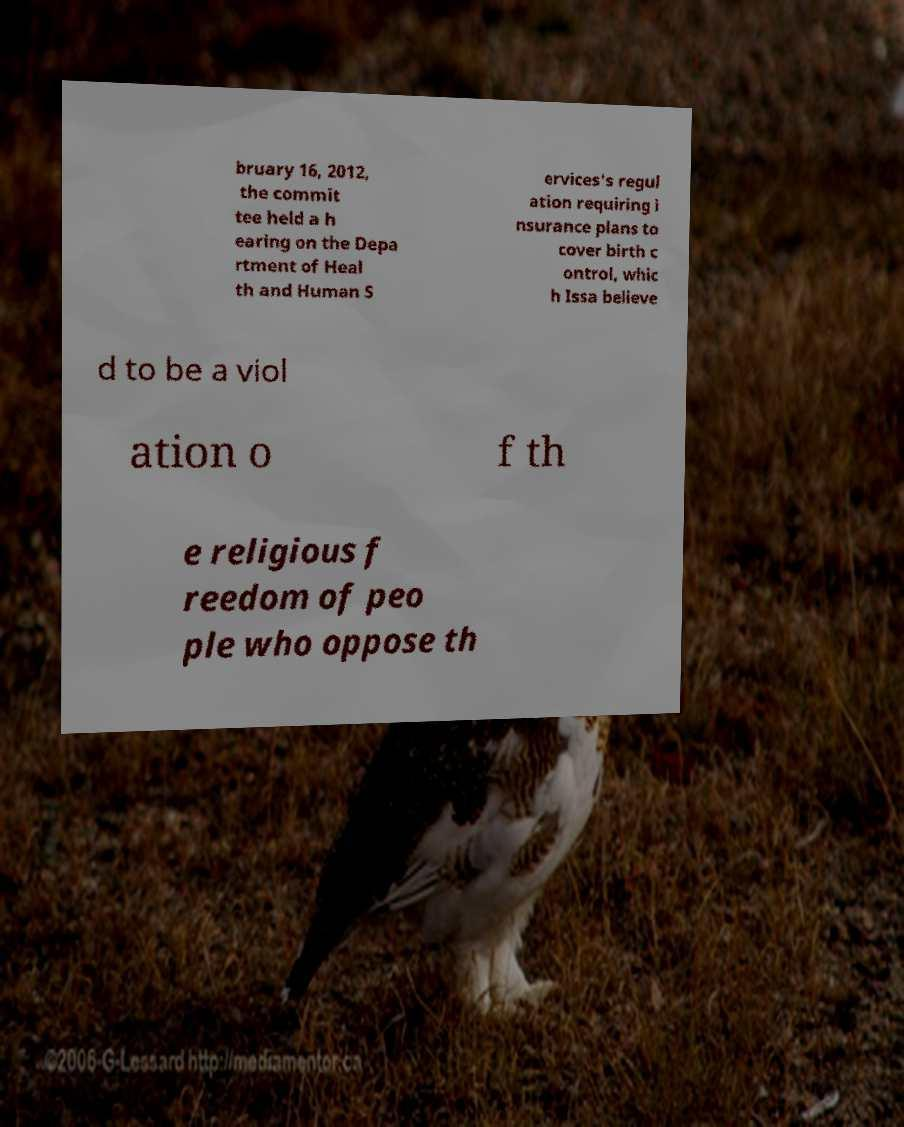Can you accurately transcribe the text from the provided image for me? bruary 16, 2012, the commit tee held a h earing on the Depa rtment of Heal th and Human S ervices's regul ation requiring i nsurance plans to cover birth c ontrol, whic h Issa believe d to be a viol ation o f th e religious f reedom of peo ple who oppose th 